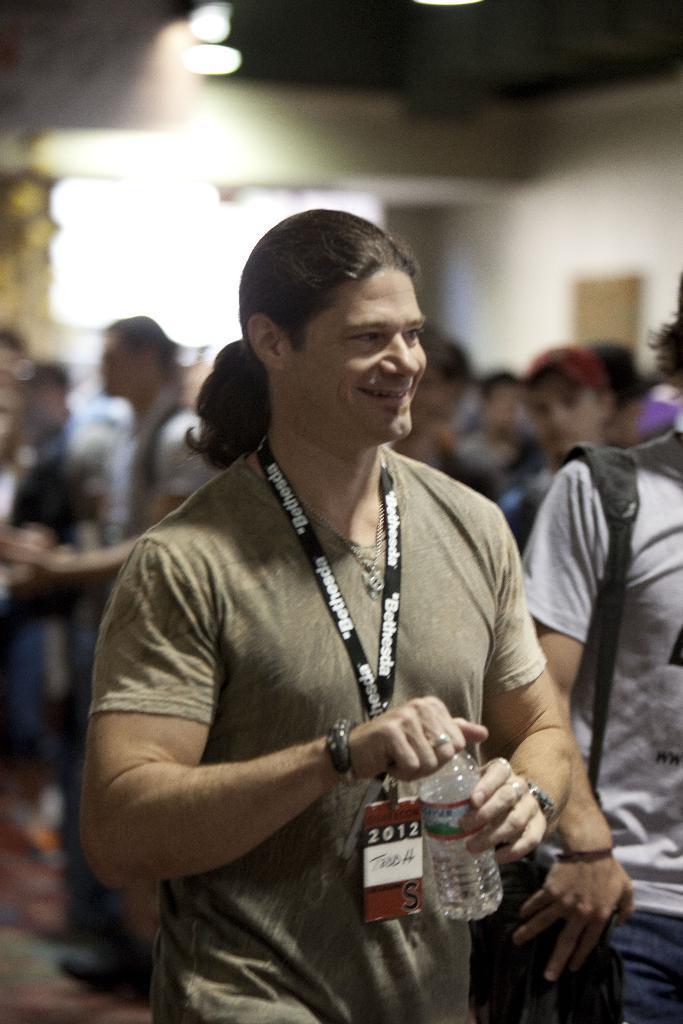Could you give a brief overview of what you see in this image? In this image I can see some people. At the top I can see the light. 